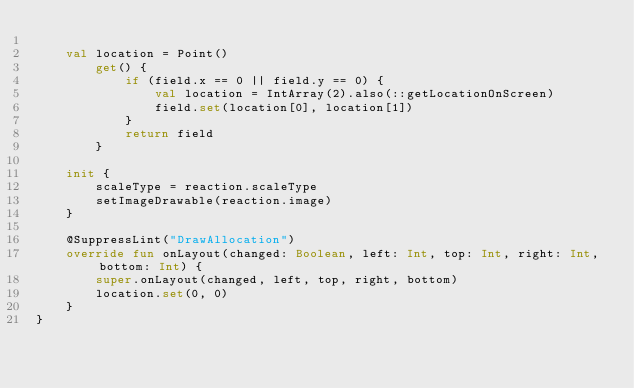<code> <loc_0><loc_0><loc_500><loc_500><_Kotlin_>
    val location = Point()
        get() {
            if (field.x == 0 || field.y == 0) {
                val location = IntArray(2).also(::getLocationOnScreen)
                field.set(location[0], location[1])
            }
            return field
        }

    init {
        scaleType = reaction.scaleType
        setImageDrawable(reaction.image)
    }

    @SuppressLint("DrawAllocation")
    override fun onLayout(changed: Boolean, left: Int, top: Int, right: Int, bottom: Int) {
        super.onLayout(changed, left, top, right, bottom)
        location.set(0, 0)
    }
}
</code> 